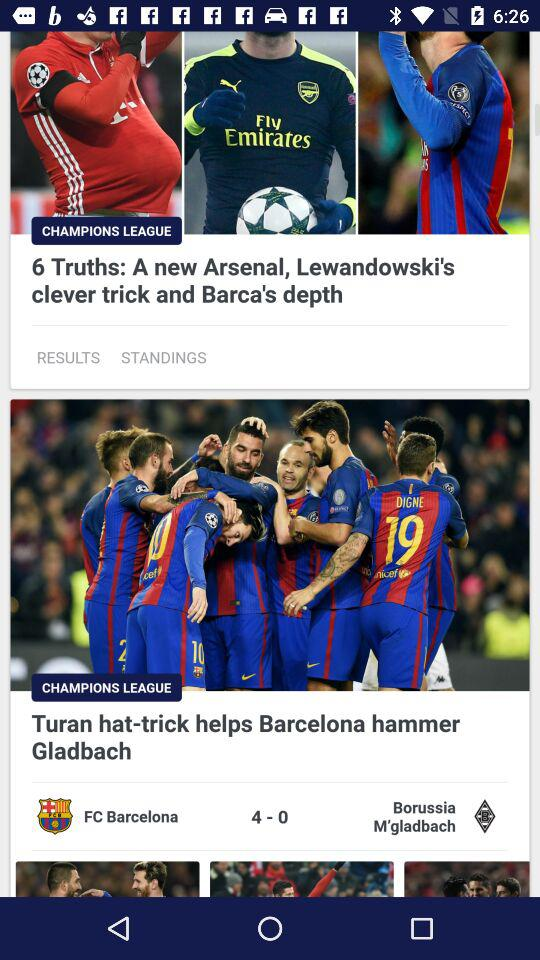How many more goals did Barcelona score than Borussia M'gladbach?
Answer the question using a single word or phrase. 4 